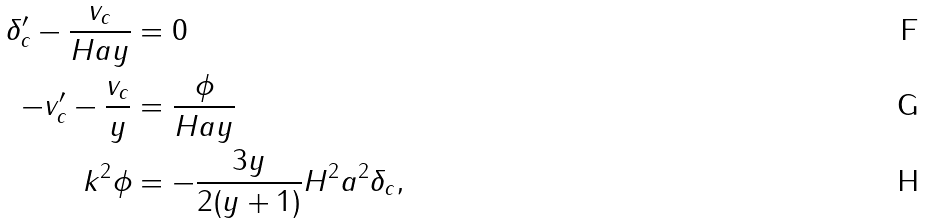<formula> <loc_0><loc_0><loc_500><loc_500>\delta ^ { \prime } _ { c } - \frac { v _ { c } } { H a y } & = 0 \\ - v ^ { \prime } _ { c } - \frac { v _ { c } } { y } & = \frac { \phi } { H a y } \\ k ^ { 2 } \phi & = - \frac { 3 y } { 2 ( y + 1 ) } H ^ { 2 } a ^ { 2 } \delta _ { c } ,</formula> 